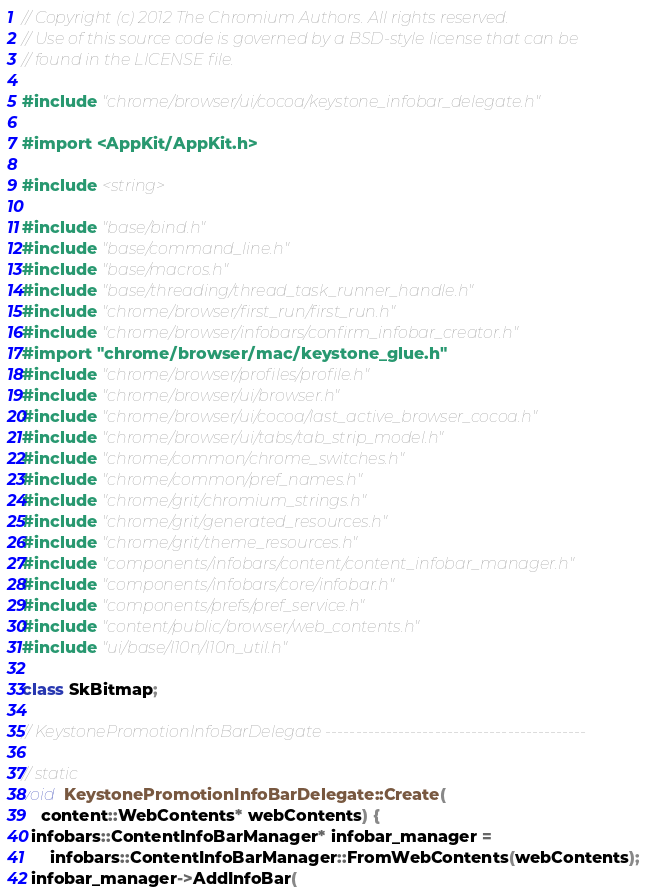Convert code to text. <code><loc_0><loc_0><loc_500><loc_500><_ObjectiveC_>// Copyright (c) 2012 The Chromium Authors. All rights reserved.
// Use of this source code is governed by a BSD-style license that can be
// found in the LICENSE file.

#include "chrome/browser/ui/cocoa/keystone_infobar_delegate.h"

#import <AppKit/AppKit.h>

#include <string>

#include "base/bind.h"
#include "base/command_line.h"
#include "base/macros.h"
#include "base/threading/thread_task_runner_handle.h"
#include "chrome/browser/first_run/first_run.h"
#include "chrome/browser/infobars/confirm_infobar_creator.h"
#import "chrome/browser/mac/keystone_glue.h"
#include "chrome/browser/profiles/profile.h"
#include "chrome/browser/ui/browser.h"
#include "chrome/browser/ui/cocoa/last_active_browser_cocoa.h"
#include "chrome/browser/ui/tabs/tab_strip_model.h"
#include "chrome/common/chrome_switches.h"
#include "chrome/common/pref_names.h"
#include "chrome/grit/chromium_strings.h"
#include "chrome/grit/generated_resources.h"
#include "chrome/grit/theme_resources.h"
#include "components/infobars/content/content_infobar_manager.h"
#include "components/infobars/core/infobar.h"
#include "components/prefs/pref_service.h"
#include "content/public/browser/web_contents.h"
#include "ui/base/l10n/l10n_util.h"

class SkBitmap;

// KeystonePromotionInfoBarDelegate -------------------------------------------

// static
void KeystonePromotionInfoBarDelegate::Create(
    content::WebContents* webContents) {
  infobars::ContentInfoBarManager* infobar_manager =
      infobars::ContentInfoBarManager::FromWebContents(webContents);
  infobar_manager->AddInfoBar(</code> 